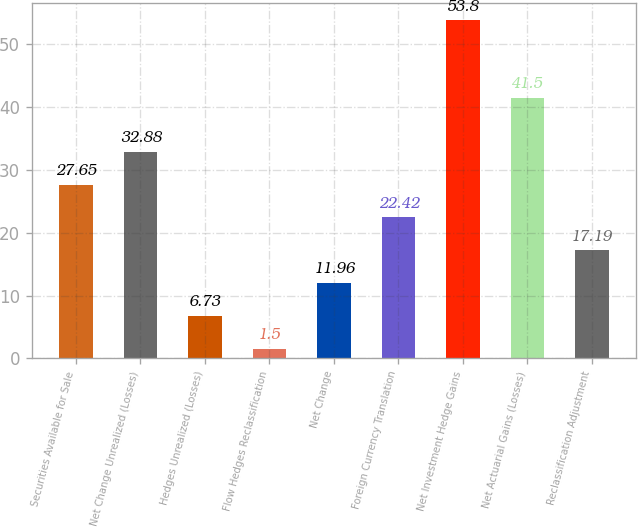<chart> <loc_0><loc_0><loc_500><loc_500><bar_chart><fcel>Securities Available for Sale<fcel>Net Change Unrealized (Losses)<fcel>Hedges Unrealized (Losses)<fcel>Flow Hedges Reclassification<fcel>Net Change<fcel>Foreign Currency Translation<fcel>Net Investment Hedge Gains<fcel>Net Actuarial Gains (Losses)<fcel>Reclassification Adjustment<nl><fcel>27.65<fcel>32.88<fcel>6.73<fcel>1.5<fcel>11.96<fcel>22.42<fcel>53.8<fcel>41.5<fcel>17.19<nl></chart> 